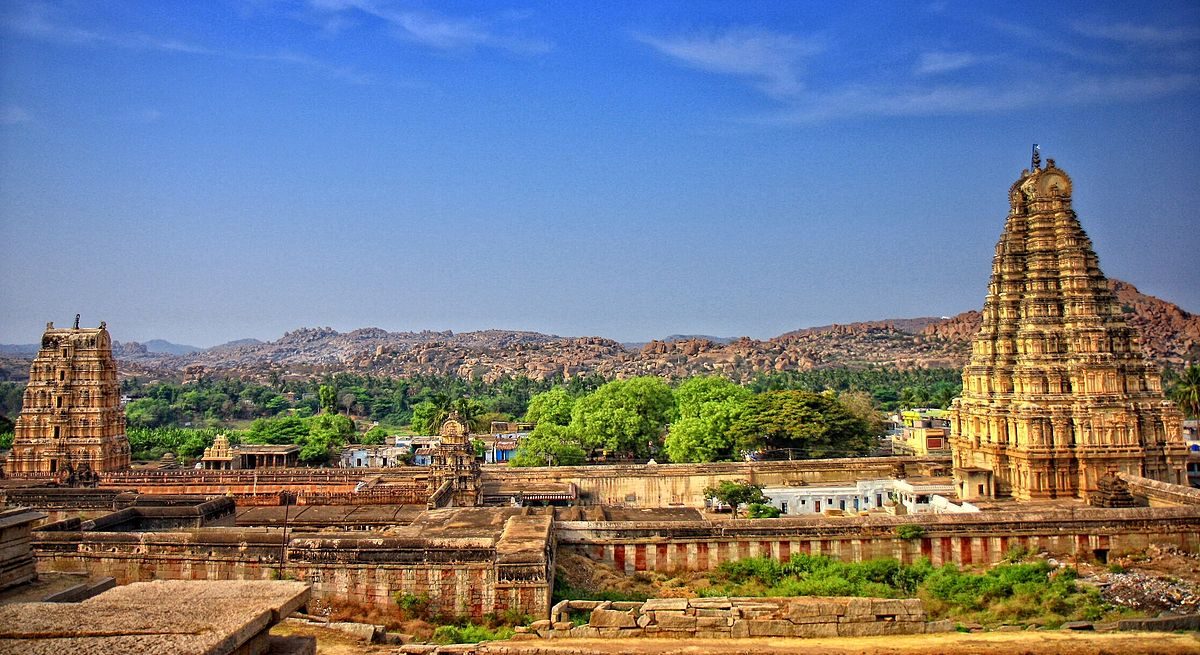How has the temple's environment influenced the local culture? The Virupaksha Temple has been an integral part of the local culture, influencing it in numerous ways. As a longstanding place of worship, it has shaped the religious practices and festivities in the area, with the annual chariot festival drawing vast numbers of devotees. The temple's presence amidst the stunning boulder-strewn landscape of Hampi has also fostered a deep appreciation for the interplay between nature and spirituality among the locals. Additionally, the Hampi Bazaar, visible in the image as a series of structures leading up to the temple, has traditionally been the hub of daily commerce and an intersection of various cultural exchanges, underscoring the importance of the temple in the socio-economic fabric of the region. 